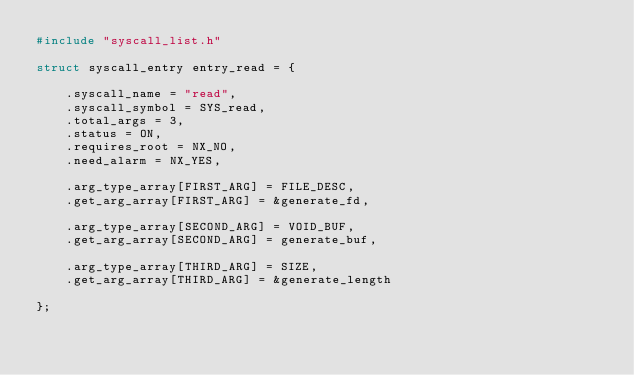Convert code to text. <code><loc_0><loc_0><loc_500><loc_500><_C_>#include "syscall_list.h"

struct syscall_entry entry_read = {

    .syscall_name = "read",
    .syscall_symbol = SYS_read,
    .total_args = 3,
    .status = ON,
    .requires_root = NX_NO,
    .need_alarm = NX_YES,

    .arg_type_array[FIRST_ARG] = FILE_DESC,
    .get_arg_array[FIRST_ARG] = &generate_fd,

    .arg_type_array[SECOND_ARG] = VOID_BUF,
    .get_arg_array[SECOND_ARG] = generate_buf,

    .arg_type_array[THIRD_ARG] = SIZE,
    .get_arg_array[THIRD_ARG] = &generate_length

};</code> 